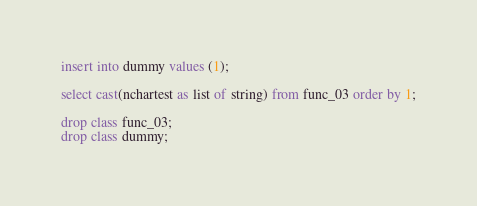Convert code to text. <code><loc_0><loc_0><loc_500><loc_500><_SQL_>insert into dummy values (1);

select cast(nchartest as list of string) from func_03 order by 1;

drop class func_03;
drop class dummy;
</code> 